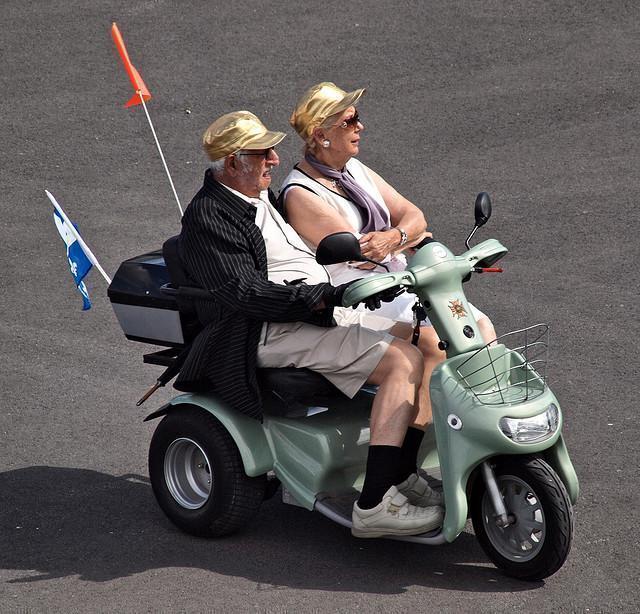Why are two of them on that little vehicle?
Answer the question by selecting the correct answer among the 4 following choices.
Options: Lacking vehicles, are fighting, are hiding, economical transportation. Economical transportation. 